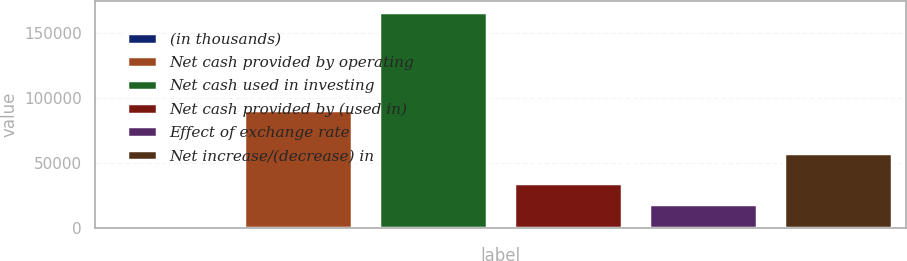Convert chart to OTSL. <chart><loc_0><loc_0><loc_500><loc_500><bar_chart><fcel>(in thousands)<fcel>Net cash provided by operating<fcel>Net cash used in investing<fcel>Net cash provided by (used in)<fcel>Effect of exchange rate<fcel>Net increase/(decrease) in<nl><fcel>2008<fcel>90744<fcel>166717<fcel>34949.8<fcel>18478.9<fcel>57564<nl></chart> 